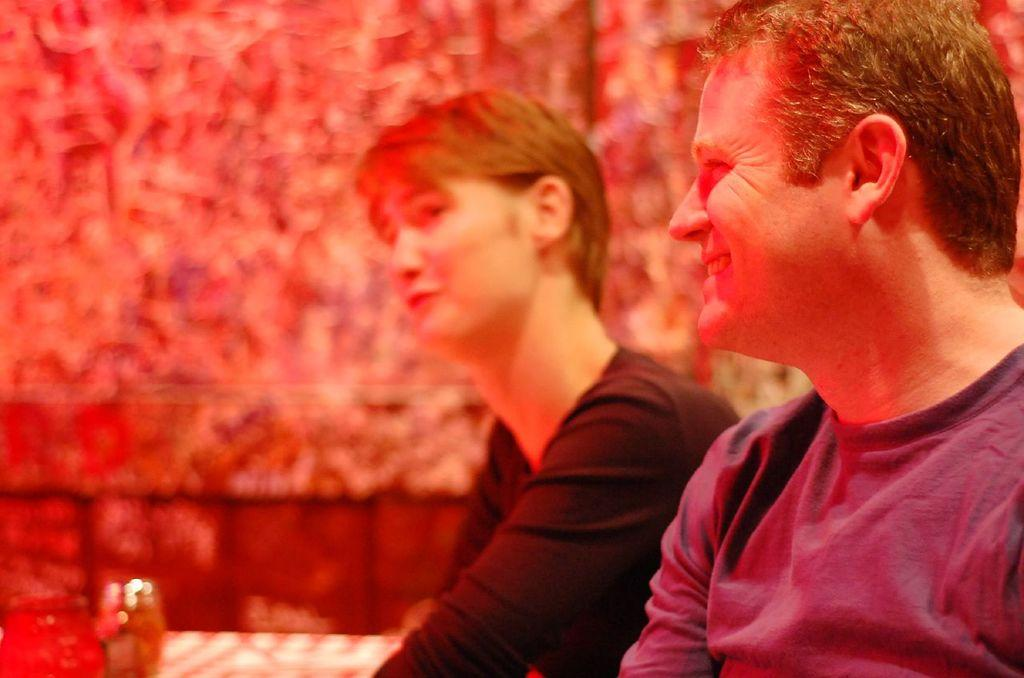How many people are present in the image? There are two people sitting in the image. What can be observed about the background of the image? The background of the image appears to be red in color. What is the main subject of the image? The image seems to depict an object. How many clocks can be seen hanging from the stream in the image? There are no clocks or streams present in the image. What type of balloon is being held by the people in the image? There are no balloons visible in the image. 